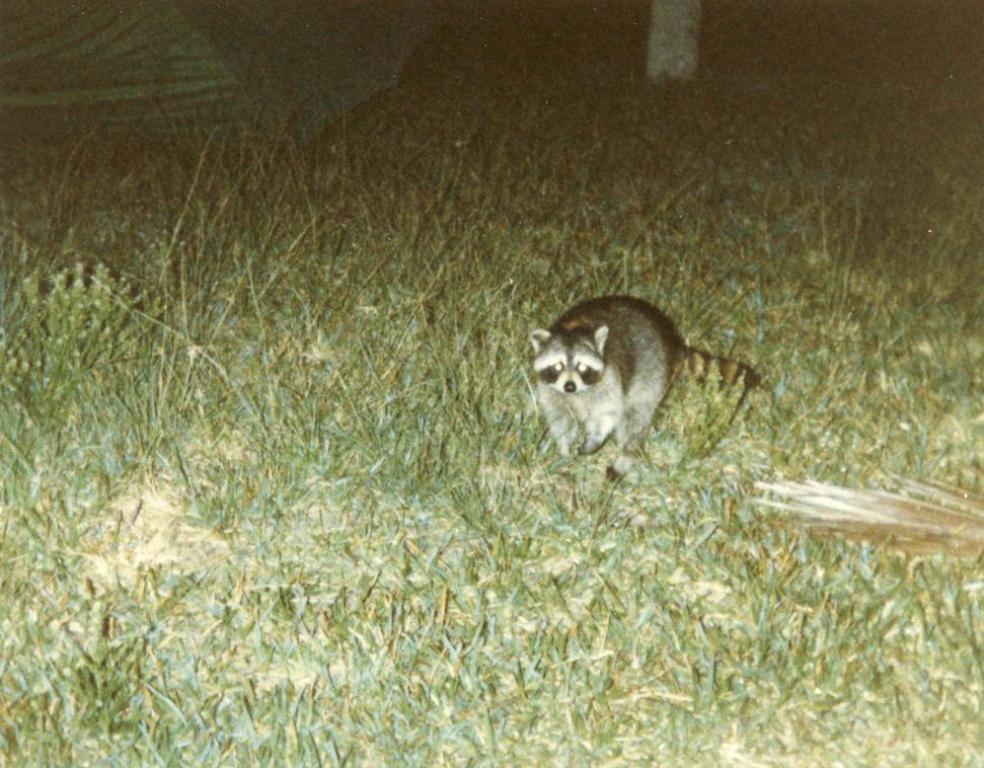Could you give a brief overview of what you see in this image? In the picture we can see a grass surface on it we can see a animal and behind it we can see a tent which is green in color. 